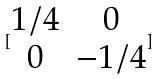<formula> <loc_0><loc_0><loc_500><loc_500>[ \begin{matrix} 1 / 4 & 0 \\ 0 & - 1 / 4 \end{matrix} ]</formula> 